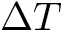<formula> <loc_0><loc_0><loc_500><loc_500>\Delta T</formula> 